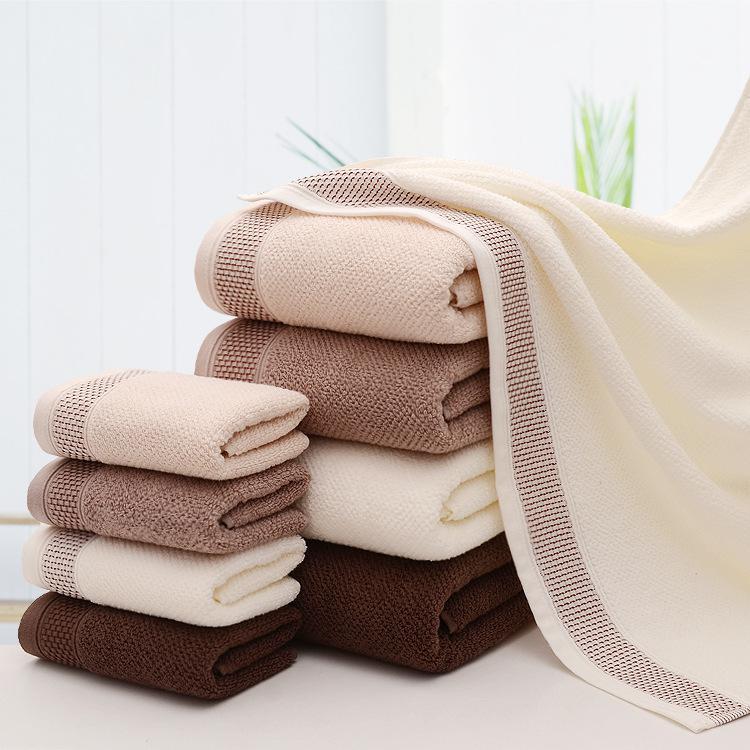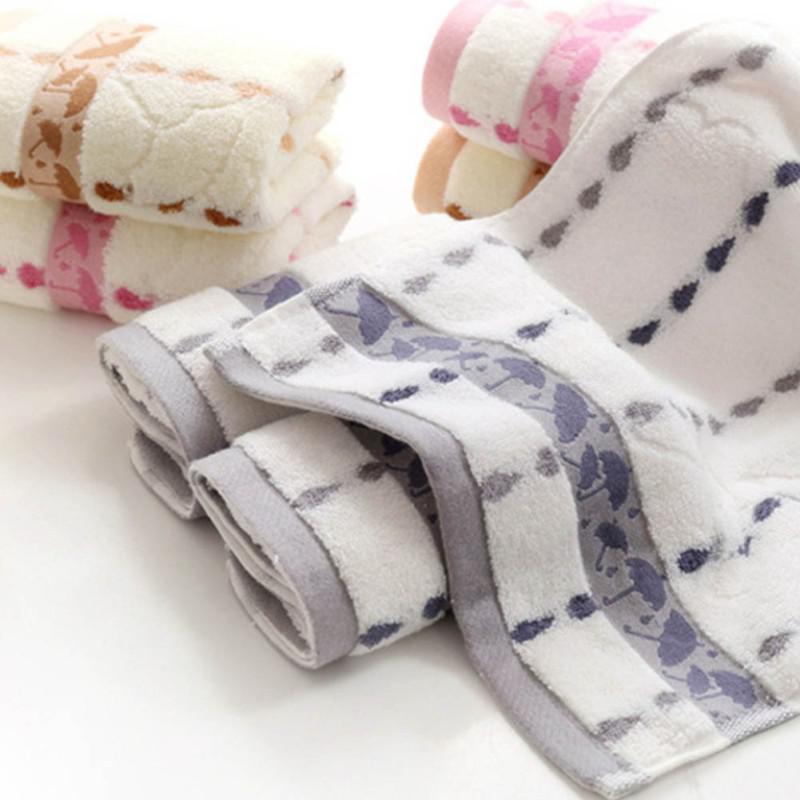The first image is the image on the left, the second image is the image on the right. Given the left and right images, does the statement "There is a towel draped over a basket in one of the images." hold true? Answer yes or no. No. 